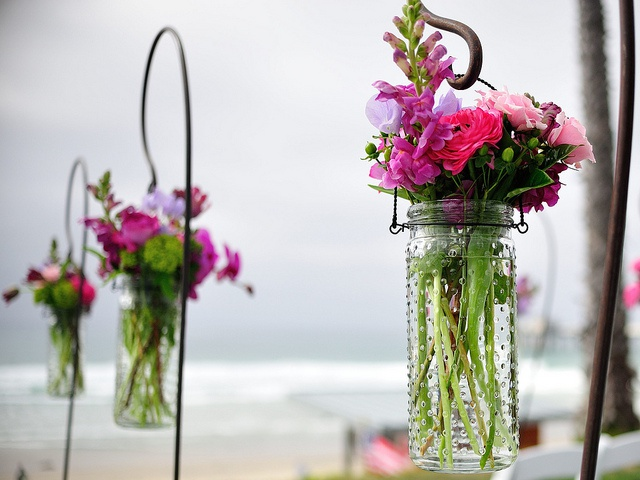Describe the objects in this image and their specific colors. I can see vase in gray, lightgray, darkgray, olive, and darkgreen tones, vase in gray, olive, black, darkgray, and darkgreen tones, and vase in gray, darkgray, darkgreen, black, and olive tones in this image. 